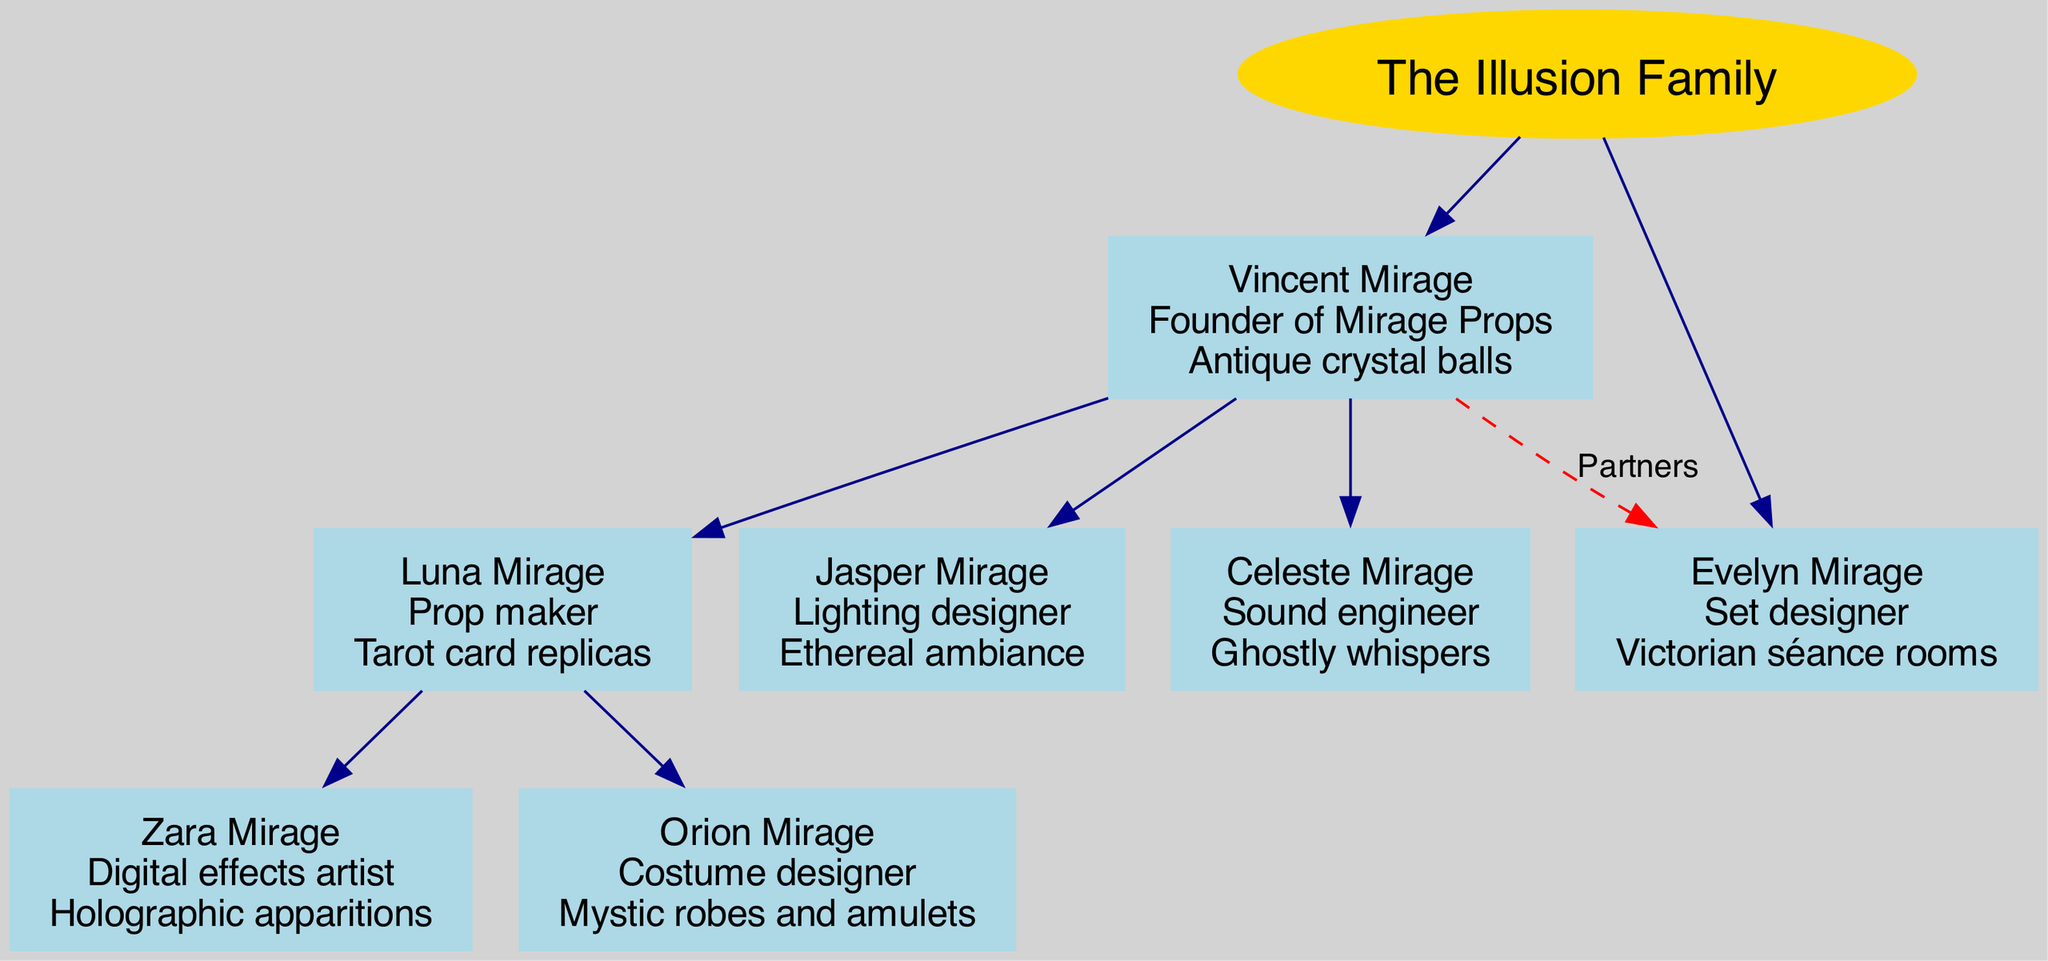What is the name of the founder of Mirage Props? The root node shows the founder of the family tree as Vincent Mirage. Therefore, the answer is derived directly from the diagram showing Vincent Mirage at the top.
Answer: Vincent Mirage How many children does Evelyn Mirage have? On examining the second generation in the diagram, Evelyn Mirage is listed under the first generation and has a total of three children listed directly beneath her node. Thus, the answer is confirmed by counting these children.
Answer: 3 Who has a specialty in "Ethereal ambiance"? By looking at the members in the second generation, Jasper Mirage is identified as the lighting designer with the specialty of creating "Ethereal ambiance." This information is directly shown in the node related to Jasper Mirage.
Answer: Jasper Mirage What is the occupation of Celeste Mirage? From the nodes in the second generation, Celeste Mirage is identified as a sound engineer. This information is part of her node data in the diagram.
Answer: Sound engineer Who is the digital effects artist in the family tree? In the diagram, Zara Mirage is clearly labeled as the digital effects artist, and this information appears directly in her node within the family tree structure.
Answer: Zara Mirage What specialty does Orion Mirage focus on? The diagram points out that Orion Mirage specializes in "Mystic robes and amulets." This information comes from the node detailing Orion Mirage’s occupation and specialty.
Answer: Mystic robes and amulets Which two members are connected as partners? Looking closely at the first generation, it is depicted that Vincent and Evelyn Mirage are connected by a dashed line symbolizing their partnership. This connection serves as a key relationship recognition within the diagram.
Answer: Vincent and Evelyn Mirage Who occupies the last generation shown in the diagram? The last generation consists of two members, Zara and Orion Mirage, who follow directly from the parent-child relationships labeled under the second generation. Thus, their names can be identified from the specified section of the diagram.
Answer: Zara and Orion Mirage How many generations are represented in the diagram? The diagram has three distinct generations: the founders (first generation), their children (second generation), and the additional children (third generation) provide insight into the family structure. Counting these gives the total number of generations present.
Answer: 3 